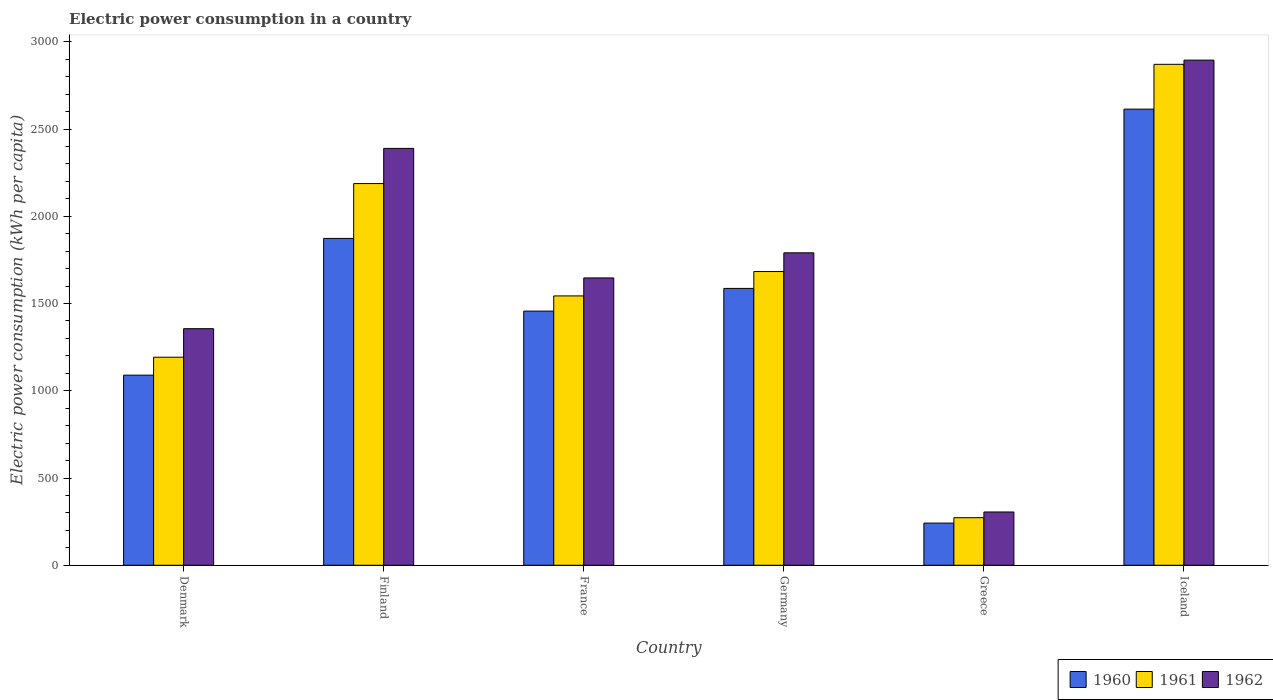How many different coloured bars are there?
Your response must be concise. 3. Are the number of bars per tick equal to the number of legend labels?
Your response must be concise. Yes. Are the number of bars on each tick of the X-axis equal?
Provide a short and direct response. Yes. What is the label of the 4th group of bars from the left?
Your answer should be compact. Germany. In how many cases, is the number of bars for a given country not equal to the number of legend labels?
Offer a very short reply. 0. What is the electric power consumption in in 1961 in Germany?
Ensure brevity in your answer.  1683.41. Across all countries, what is the maximum electric power consumption in in 1962?
Provide a succinct answer. 2895.09. Across all countries, what is the minimum electric power consumption in in 1962?
Give a very brief answer. 305.39. What is the total electric power consumption in in 1962 in the graph?
Your answer should be very brief. 1.04e+04. What is the difference between the electric power consumption in in 1960 in Finland and that in Iceland?
Give a very brief answer. -740.99. What is the difference between the electric power consumption in in 1960 in Iceland and the electric power consumption in in 1962 in Greece?
Your answer should be very brief. 2308.89. What is the average electric power consumption in in 1960 per country?
Ensure brevity in your answer.  1477.06. What is the difference between the electric power consumption in of/in 1960 and electric power consumption in of/in 1962 in Iceland?
Provide a short and direct response. -280.8. In how many countries, is the electric power consumption in in 1960 greater than 1600 kWh per capita?
Your response must be concise. 2. What is the ratio of the electric power consumption in in 1960 in France to that in Iceland?
Provide a succinct answer. 0.56. Is the difference between the electric power consumption in in 1960 in Denmark and Greece greater than the difference between the electric power consumption in in 1962 in Denmark and Greece?
Provide a succinct answer. No. What is the difference between the highest and the second highest electric power consumption in in 1962?
Provide a short and direct response. 598.52. What is the difference between the highest and the lowest electric power consumption in in 1960?
Offer a very short reply. 2372.56. In how many countries, is the electric power consumption in in 1960 greater than the average electric power consumption in in 1960 taken over all countries?
Make the answer very short. 3. What does the 3rd bar from the right in France represents?
Make the answer very short. 1960. Is it the case that in every country, the sum of the electric power consumption in in 1960 and electric power consumption in in 1962 is greater than the electric power consumption in in 1961?
Ensure brevity in your answer.  Yes. How many countries are there in the graph?
Keep it short and to the point. 6. Does the graph contain any zero values?
Give a very brief answer. No. Does the graph contain grids?
Offer a terse response. No. What is the title of the graph?
Keep it short and to the point. Electric power consumption in a country. What is the label or title of the Y-axis?
Ensure brevity in your answer.  Electric power consumption (kWh per capita). What is the Electric power consumption (kWh per capita) of 1960 in Denmark?
Your response must be concise. 1089.61. What is the Electric power consumption (kWh per capita) of 1961 in Denmark?
Your answer should be compact. 1192.41. What is the Electric power consumption (kWh per capita) of 1962 in Denmark?
Your answer should be very brief. 1355.93. What is the Electric power consumption (kWh per capita) of 1960 in Finland?
Give a very brief answer. 1873.29. What is the Electric power consumption (kWh per capita) of 1961 in Finland?
Make the answer very short. 2187.62. What is the Electric power consumption (kWh per capita) in 1962 in Finland?
Your answer should be compact. 2389.21. What is the Electric power consumption (kWh per capita) in 1960 in France?
Your answer should be compact. 1456.69. What is the Electric power consumption (kWh per capita) in 1961 in France?
Provide a short and direct response. 1543.71. What is the Electric power consumption (kWh per capita) of 1962 in France?
Keep it short and to the point. 1646.83. What is the Electric power consumption (kWh per capita) in 1960 in Germany?
Your answer should be compact. 1586.75. What is the Electric power consumption (kWh per capita) in 1961 in Germany?
Ensure brevity in your answer.  1683.41. What is the Electric power consumption (kWh per capita) of 1962 in Germany?
Keep it short and to the point. 1790.69. What is the Electric power consumption (kWh per capita) of 1960 in Greece?
Your answer should be compact. 241.73. What is the Electric power consumption (kWh per capita) in 1961 in Greece?
Your response must be concise. 272.56. What is the Electric power consumption (kWh per capita) in 1962 in Greece?
Offer a terse response. 305.39. What is the Electric power consumption (kWh per capita) in 1960 in Iceland?
Provide a succinct answer. 2614.28. What is the Electric power consumption (kWh per capita) of 1961 in Iceland?
Provide a succinct answer. 2871.04. What is the Electric power consumption (kWh per capita) of 1962 in Iceland?
Offer a very short reply. 2895.09. Across all countries, what is the maximum Electric power consumption (kWh per capita) in 1960?
Provide a succinct answer. 2614.28. Across all countries, what is the maximum Electric power consumption (kWh per capita) of 1961?
Your response must be concise. 2871.04. Across all countries, what is the maximum Electric power consumption (kWh per capita) in 1962?
Ensure brevity in your answer.  2895.09. Across all countries, what is the minimum Electric power consumption (kWh per capita) of 1960?
Make the answer very short. 241.73. Across all countries, what is the minimum Electric power consumption (kWh per capita) in 1961?
Provide a succinct answer. 272.56. Across all countries, what is the minimum Electric power consumption (kWh per capita) in 1962?
Offer a very short reply. 305.39. What is the total Electric power consumption (kWh per capita) in 1960 in the graph?
Give a very brief answer. 8862.36. What is the total Electric power consumption (kWh per capita) of 1961 in the graph?
Make the answer very short. 9750.76. What is the total Electric power consumption (kWh per capita) in 1962 in the graph?
Provide a succinct answer. 1.04e+04. What is the difference between the Electric power consumption (kWh per capita) of 1960 in Denmark and that in Finland?
Your answer should be very brief. -783.68. What is the difference between the Electric power consumption (kWh per capita) of 1961 in Denmark and that in Finland?
Provide a succinct answer. -995.22. What is the difference between the Electric power consumption (kWh per capita) in 1962 in Denmark and that in Finland?
Provide a succinct answer. -1033.28. What is the difference between the Electric power consumption (kWh per capita) in 1960 in Denmark and that in France?
Provide a succinct answer. -367.08. What is the difference between the Electric power consumption (kWh per capita) in 1961 in Denmark and that in France?
Your response must be concise. -351.31. What is the difference between the Electric power consumption (kWh per capita) in 1962 in Denmark and that in France?
Provide a succinct answer. -290.9. What is the difference between the Electric power consumption (kWh per capita) of 1960 in Denmark and that in Germany?
Make the answer very short. -497.14. What is the difference between the Electric power consumption (kWh per capita) in 1961 in Denmark and that in Germany?
Give a very brief answer. -491.01. What is the difference between the Electric power consumption (kWh per capita) of 1962 in Denmark and that in Germany?
Give a very brief answer. -434.76. What is the difference between the Electric power consumption (kWh per capita) in 1960 in Denmark and that in Greece?
Provide a succinct answer. 847.89. What is the difference between the Electric power consumption (kWh per capita) in 1961 in Denmark and that in Greece?
Your response must be concise. 919.84. What is the difference between the Electric power consumption (kWh per capita) in 1962 in Denmark and that in Greece?
Your response must be concise. 1050.54. What is the difference between the Electric power consumption (kWh per capita) in 1960 in Denmark and that in Iceland?
Your response must be concise. -1524.67. What is the difference between the Electric power consumption (kWh per capita) of 1961 in Denmark and that in Iceland?
Keep it short and to the point. -1678.64. What is the difference between the Electric power consumption (kWh per capita) of 1962 in Denmark and that in Iceland?
Your answer should be compact. -1539.15. What is the difference between the Electric power consumption (kWh per capita) of 1960 in Finland and that in France?
Offer a terse response. 416.6. What is the difference between the Electric power consumption (kWh per capita) in 1961 in Finland and that in France?
Offer a terse response. 643.91. What is the difference between the Electric power consumption (kWh per capita) in 1962 in Finland and that in France?
Your answer should be very brief. 742.38. What is the difference between the Electric power consumption (kWh per capita) of 1960 in Finland and that in Germany?
Provide a short and direct response. 286.54. What is the difference between the Electric power consumption (kWh per capita) of 1961 in Finland and that in Germany?
Provide a succinct answer. 504.21. What is the difference between the Electric power consumption (kWh per capita) in 1962 in Finland and that in Germany?
Your answer should be compact. 598.52. What is the difference between the Electric power consumption (kWh per capita) of 1960 in Finland and that in Greece?
Make the answer very short. 1631.57. What is the difference between the Electric power consumption (kWh per capita) in 1961 in Finland and that in Greece?
Your response must be concise. 1915.06. What is the difference between the Electric power consumption (kWh per capita) in 1962 in Finland and that in Greece?
Keep it short and to the point. 2083.82. What is the difference between the Electric power consumption (kWh per capita) in 1960 in Finland and that in Iceland?
Your answer should be very brief. -740.99. What is the difference between the Electric power consumption (kWh per capita) in 1961 in Finland and that in Iceland?
Provide a short and direct response. -683.42. What is the difference between the Electric power consumption (kWh per capita) of 1962 in Finland and that in Iceland?
Provide a short and direct response. -505.88. What is the difference between the Electric power consumption (kWh per capita) in 1960 in France and that in Germany?
Keep it short and to the point. -130.06. What is the difference between the Electric power consumption (kWh per capita) in 1961 in France and that in Germany?
Your response must be concise. -139.7. What is the difference between the Electric power consumption (kWh per capita) in 1962 in France and that in Germany?
Provide a succinct answer. -143.85. What is the difference between the Electric power consumption (kWh per capita) of 1960 in France and that in Greece?
Offer a very short reply. 1214.97. What is the difference between the Electric power consumption (kWh per capita) in 1961 in France and that in Greece?
Ensure brevity in your answer.  1271.15. What is the difference between the Electric power consumption (kWh per capita) of 1962 in France and that in Greece?
Keep it short and to the point. 1341.44. What is the difference between the Electric power consumption (kWh per capita) of 1960 in France and that in Iceland?
Provide a short and direct response. -1157.59. What is the difference between the Electric power consumption (kWh per capita) in 1961 in France and that in Iceland?
Your answer should be very brief. -1327.33. What is the difference between the Electric power consumption (kWh per capita) of 1962 in France and that in Iceland?
Keep it short and to the point. -1248.25. What is the difference between the Electric power consumption (kWh per capita) of 1960 in Germany and that in Greece?
Your response must be concise. 1345.02. What is the difference between the Electric power consumption (kWh per capita) of 1961 in Germany and that in Greece?
Offer a terse response. 1410.85. What is the difference between the Electric power consumption (kWh per capita) in 1962 in Germany and that in Greece?
Keep it short and to the point. 1485.3. What is the difference between the Electric power consumption (kWh per capita) of 1960 in Germany and that in Iceland?
Make the answer very short. -1027.53. What is the difference between the Electric power consumption (kWh per capita) in 1961 in Germany and that in Iceland?
Ensure brevity in your answer.  -1187.63. What is the difference between the Electric power consumption (kWh per capita) of 1962 in Germany and that in Iceland?
Make the answer very short. -1104.4. What is the difference between the Electric power consumption (kWh per capita) in 1960 in Greece and that in Iceland?
Give a very brief answer. -2372.56. What is the difference between the Electric power consumption (kWh per capita) of 1961 in Greece and that in Iceland?
Keep it short and to the point. -2598.48. What is the difference between the Electric power consumption (kWh per capita) of 1962 in Greece and that in Iceland?
Provide a succinct answer. -2589.7. What is the difference between the Electric power consumption (kWh per capita) in 1960 in Denmark and the Electric power consumption (kWh per capita) in 1961 in Finland?
Ensure brevity in your answer.  -1098.01. What is the difference between the Electric power consumption (kWh per capita) in 1960 in Denmark and the Electric power consumption (kWh per capita) in 1962 in Finland?
Provide a succinct answer. -1299.6. What is the difference between the Electric power consumption (kWh per capita) in 1961 in Denmark and the Electric power consumption (kWh per capita) in 1962 in Finland?
Provide a succinct answer. -1196.8. What is the difference between the Electric power consumption (kWh per capita) of 1960 in Denmark and the Electric power consumption (kWh per capita) of 1961 in France?
Make the answer very short. -454.1. What is the difference between the Electric power consumption (kWh per capita) of 1960 in Denmark and the Electric power consumption (kWh per capita) of 1962 in France?
Give a very brief answer. -557.22. What is the difference between the Electric power consumption (kWh per capita) in 1961 in Denmark and the Electric power consumption (kWh per capita) in 1962 in France?
Give a very brief answer. -454.43. What is the difference between the Electric power consumption (kWh per capita) in 1960 in Denmark and the Electric power consumption (kWh per capita) in 1961 in Germany?
Offer a terse response. -593.8. What is the difference between the Electric power consumption (kWh per capita) of 1960 in Denmark and the Electric power consumption (kWh per capita) of 1962 in Germany?
Make the answer very short. -701.07. What is the difference between the Electric power consumption (kWh per capita) in 1961 in Denmark and the Electric power consumption (kWh per capita) in 1962 in Germany?
Keep it short and to the point. -598.28. What is the difference between the Electric power consumption (kWh per capita) of 1960 in Denmark and the Electric power consumption (kWh per capita) of 1961 in Greece?
Provide a short and direct response. 817.05. What is the difference between the Electric power consumption (kWh per capita) in 1960 in Denmark and the Electric power consumption (kWh per capita) in 1962 in Greece?
Provide a succinct answer. 784.22. What is the difference between the Electric power consumption (kWh per capita) of 1961 in Denmark and the Electric power consumption (kWh per capita) of 1962 in Greece?
Provide a succinct answer. 887.02. What is the difference between the Electric power consumption (kWh per capita) of 1960 in Denmark and the Electric power consumption (kWh per capita) of 1961 in Iceland?
Ensure brevity in your answer.  -1781.43. What is the difference between the Electric power consumption (kWh per capita) of 1960 in Denmark and the Electric power consumption (kWh per capita) of 1962 in Iceland?
Offer a terse response. -1805.47. What is the difference between the Electric power consumption (kWh per capita) in 1961 in Denmark and the Electric power consumption (kWh per capita) in 1962 in Iceland?
Provide a succinct answer. -1702.68. What is the difference between the Electric power consumption (kWh per capita) in 1960 in Finland and the Electric power consumption (kWh per capita) in 1961 in France?
Provide a succinct answer. 329.58. What is the difference between the Electric power consumption (kWh per capita) in 1960 in Finland and the Electric power consumption (kWh per capita) in 1962 in France?
Give a very brief answer. 226.46. What is the difference between the Electric power consumption (kWh per capita) of 1961 in Finland and the Electric power consumption (kWh per capita) of 1962 in France?
Your response must be concise. 540.79. What is the difference between the Electric power consumption (kWh per capita) in 1960 in Finland and the Electric power consumption (kWh per capita) in 1961 in Germany?
Offer a very short reply. 189.88. What is the difference between the Electric power consumption (kWh per capita) of 1960 in Finland and the Electric power consumption (kWh per capita) of 1962 in Germany?
Ensure brevity in your answer.  82.61. What is the difference between the Electric power consumption (kWh per capita) in 1961 in Finland and the Electric power consumption (kWh per capita) in 1962 in Germany?
Provide a short and direct response. 396.94. What is the difference between the Electric power consumption (kWh per capita) of 1960 in Finland and the Electric power consumption (kWh per capita) of 1961 in Greece?
Your response must be concise. 1600.73. What is the difference between the Electric power consumption (kWh per capita) of 1960 in Finland and the Electric power consumption (kWh per capita) of 1962 in Greece?
Give a very brief answer. 1567.9. What is the difference between the Electric power consumption (kWh per capita) in 1961 in Finland and the Electric power consumption (kWh per capita) in 1962 in Greece?
Your response must be concise. 1882.23. What is the difference between the Electric power consumption (kWh per capita) of 1960 in Finland and the Electric power consumption (kWh per capita) of 1961 in Iceland?
Give a very brief answer. -997.75. What is the difference between the Electric power consumption (kWh per capita) in 1960 in Finland and the Electric power consumption (kWh per capita) in 1962 in Iceland?
Ensure brevity in your answer.  -1021.79. What is the difference between the Electric power consumption (kWh per capita) of 1961 in Finland and the Electric power consumption (kWh per capita) of 1962 in Iceland?
Offer a terse response. -707.46. What is the difference between the Electric power consumption (kWh per capita) of 1960 in France and the Electric power consumption (kWh per capita) of 1961 in Germany?
Ensure brevity in your answer.  -226.72. What is the difference between the Electric power consumption (kWh per capita) of 1960 in France and the Electric power consumption (kWh per capita) of 1962 in Germany?
Make the answer very short. -333.99. What is the difference between the Electric power consumption (kWh per capita) in 1961 in France and the Electric power consumption (kWh per capita) in 1962 in Germany?
Offer a terse response. -246.98. What is the difference between the Electric power consumption (kWh per capita) of 1960 in France and the Electric power consumption (kWh per capita) of 1961 in Greece?
Provide a short and direct response. 1184.13. What is the difference between the Electric power consumption (kWh per capita) of 1960 in France and the Electric power consumption (kWh per capita) of 1962 in Greece?
Ensure brevity in your answer.  1151.3. What is the difference between the Electric power consumption (kWh per capita) in 1961 in France and the Electric power consumption (kWh per capita) in 1962 in Greece?
Ensure brevity in your answer.  1238.32. What is the difference between the Electric power consumption (kWh per capita) in 1960 in France and the Electric power consumption (kWh per capita) in 1961 in Iceland?
Your answer should be very brief. -1414.35. What is the difference between the Electric power consumption (kWh per capita) in 1960 in France and the Electric power consumption (kWh per capita) in 1962 in Iceland?
Offer a terse response. -1438.39. What is the difference between the Electric power consumption (kWh per capita) in 1961 in France and the Electric power consumption (kWh per capita) in 1962 in Iceland?
Your response must be concise. -1351.37. What is the difference between the Electric power consumption (kWh per capita) in 1960 in Germany and the Electric power consumption (kWh per capita) in 1961 in Greece?
Ensure brevity in your answer.  1314.19. What is the difference between the Electric power consumption (kWh per capita) of 1960 in Germany and the Electric power consumption (kWh per capita) of 1962 in Greece?
Your answer should be very brief. 1281.36. What is the difference between the Electric power consumption (kWh per capita) of 1961 in Germany and the Electric power consumption (kWh per capita) of 1962 in Greece?
Provide a succinct answer. 1378.03. What is the difference between the Electric power consumption (kWh per capita) in 1960 in Germany and the Electric power consumption (kWh per capita) in 1961 in Iceland?
Provide a succinct answer. -1284.29. What is the difference between the Electric power consumption (kWh per capita) in 1960 in Germany and the Electric power consumption (kWh per capita) in 1962 in Iceland?
Provide a succinct answer. -1308.34. What is the difference between the Electric power consumption (kWh per capita) of 1961 in Germany and the Electric power consumption (kWh per capita) of 1962 in Iceland?
Offer a very short reply. -1211.67. What is the difference between the Electric power consumption (kWh per capita) of 1960 in Greece and the Electric power consumption (kWh per capita) of 1961 in Iceland?
Offer a very short reply. -2629.32. What is the difference between the Electric power consumption (kWh per capita) of 1960 in Greece and the Electric power consumption (kWh per capita) of 1962 in Iceland?
Offer a very short reply. -2653.36. What is the difference between the Electric power consumption (kWh per capita) in 1961 in Greece and the Electric power consumption (kWh per capita) in 1962 in Iceland?
Your answer should be compact. -2622.52. What is the average Electric power consumption (kWh per capita) of 1960 per country?
Ensure brevity in your answer.  1477.06. What is the average Electric power consumption (kWh per capita) in 1961 per country?
Provide a short and direct response. 1625.13. What is the average Electric power consumption (kWh per capita) of 1962 per country?
Provide a short and direct response. 1730.52. What is the difference between the Electric power consumption (kWh per capita) of 1960 and Electric power consumption (kWh per capita) of 1961 in Denmark?
Provide a succinct answer. -102.79. What is the difference between the Electric power consumption (kWh per capita) of 1960 and Electric power consumption (kWh per capita) of 1962 in Denmark?
Make the answer very short. -266.32. What is the difference between the Electric power consumption (kWh per capita) in 1961 and Electric power consumption (kWh per capita) in 1962 in Denmark?
Your answer should be compact. -163.53. What is the difference between the Electric power consumption (kWh per capita) in 1960 and Electric power consumption (kWh per capita) in 1961 in Finland?
Your response must be concise. -314.33. What is the difference between the Electric power consumption (kWh per capita) of 1960 and Electric power consumption (kWh per capita) of 1962 in Finland?
Offer a very short reply. -515.92. What is the difference between the Electric power consumption (kWh per capita) in 1961 and Electric power consumption (kWh per capita) in 1962 in Finland?
Offer a very short reply. -201.59. What is the difference between the Electric power consumption (kWh per capita) of 1960 and Electric power consumption (kWh per capita) of 1961 in France?
Your response must be concise. -87.02. What is the difference between the Electric power consumption (kWh per capita) in 1960 and Electric power consumption (kWh per capita) in 1962 in France?
Your answer should be very brief. -190.14. What is the difference between the Electric power consumption (kWh per capita) of 1961 and Electric power consumption (kWh per capita) of 1962 in France?
Give a very brief answer. -103.12. What is the difference between the Electric power consumption (kWh per capita) in 1960 and Electric power consumption (kWh per capita) in 1961 in Germany?
Make the answer very short. -96.67. What is the difference between the Electric power consumption (kWh per capita) of 1960 and Electric power consumption (kWh per capita) of 1962 in Germany?
Give a very brief answer. -203.94. What is the difference between the Electric power consumption (kWh per capita) in 1961 and Electric power consumption (kWh per capita) in 1962 in Germany?
Provide a short and direct response. -107.27. What is the difference between the Electric power consumption (kWh per capita) in 1960 and Electric power consumption (kWh per capita) in 1961 in Greece?
Offer a very short reply. -30.84. What is the difference between the Electric power consumption (kWh per capita) in 1960 and Electric power consumption (kWh per capita) in 1962 in Greece?
Your answer should be compact. -63.66. What is the difference between the Electric power consumption (kWh per capita) in 1961 and Electric power consumption (kWh per capita) in 1962 in Greece?
Your response must be concise. -32.83. What is the difference between the Electric power consumption (kWh per capita) of 1960 and Electric power consumption (kWh per capita) of 1961 in Iceland?
Give a very brief answer. -256.76. What is the difference between the Electric power consumption (kWh per capita) in 1960 and Electric power consumption (kWh per capita) in 1962 in Iceland?
Offer a very short reply. -280.8. What is the difference between the Electric power consumption (kWh per capita) of 1961 and Electric power consumption (kWh per capita) of 1962 in Iceland?
Your answer should be very brief. -24.04. What is the ratio of the Electric power consumption (kWh per capita) of 1960 in Denmark to that in Finland?
Your answer should be compact. 0.58. What is the ratio of the Electric power consumption (kWh per capita) of 1961 in Denmark to that in Finland?
Offer a terse response. 0.55. What is the ratio of the Electric power consumption (kWh per capita) of 1962 in Denmark to that in Finland?
Your answer should be very brief. 0.57. What is the ratio of the Electric power consumption (kWh per capita) in 1960 in Denmark to that in France?
Give a very brief answer. 0.75. What is the ratio of the Electric power consumption (kWh per capita) of 1961 in Denmark to that in France?
Provide a short and direct response. 0.77. What is the ratio of the Electric power consumption (kWh per capita) of 1962 in Denmark to that in France?
Provide a succinct answer. 0.82. What is the ratio of the Electric power consumption (kWh per capita) in 1960 in Denmark to that in Germany?
Give a very brief answer. 0.69. What is the ratio of the Electric power consumption (kWh per capita) in 1961 in Denmark to that in Germany?
Ensure brevity in your answer.  0.71. What is the ratio of the Electric power consumption (kWh per capita) in 1962 in Denmark to that in Germany?
Make the answer very short. 0.76. What is the ratio of the Electric power consumption (kWh per capita) of 1960 in Denmark to that in Greece?
Keep it short and to the point. 4.51. What is the ratio of the Electric power consumption (kWh per capita) of 1961 in Denmark to that in Greece?
Give a very brief answer. 4.37. What is the ratio of the Electric power consumption (kWh per capita) in 1962 in Denmark to that in Greece?
Your answer should be compact. 4.44. What is the ratio of the Electric power consumption (kWh per capita) in 1960 in Denmark to that in Iceland?
Your answer should be compact. 0.42. What is the ratio of the Electric power consumption (kWh per capita) of 1961 in Denmark to that in Iceland?
Your answer should be compact. 0.42. What is the ratio of the Electric power consumption (kWh per capita) in 1962 in Denmark to that in Iceland?
Provide a short and direct response. 0.47. What is the ratio of the Electric power consumption (kWh per capita) in 1960 in Finland to that in France?
Ensure brevity in your answer.  1.29. What is the ratio of the Electric power consumption (kWh per capita) in 1961 in Finland to that in France?
Provide a succinct answer. 1.42. What is the ratio of the Electric power consumption (kWh per capita) of 1962 in Finland to that in France?
Ensure brevity in your answer.  1.45. What is the ratio of the Electric power consumption (kWh per capita) in 1960 in Finland to that in Germany?
Make the answer very short. 1.18. What is the ratio of the Electric power consumption (kWh per capita) in 1961 in Finland to that in Germany?
Make the answer very short. 1.3. What is the ratio of the Electric power consumption (kWh per capita) of 1962 in Finland to that in Germany?
Ensure brevity in your answer.  1.33. What is the ratio of the Electric power consumption (kWh per capita) in 1960 in Finland to that in Greece?
Give a very brief answer. 7.75. What is the ratio of the Electric power consumption (kWh per capita) in 1961 in Finland to that in Greece?
Offer a very short reply. 8.03. What is the ratio of the Electric power consumption (kWh per capita) in 1962 in Finland to that in Greece?
Provide a succinct answer. 7.82. What is the ratio of the Electric power consumption (kWh per capita) in 1960 in Finland to that in Iceland?
Make the answer very short. 0.72. What is the ratio of the Electric power consumption (kWh per capita) of 1961 in Finland to that in Iceland?
Your response must be concise. 0.76. What is the ratio of the Electric power consumption (kWh per capita) in 1962 in Finland to that in Iceland?
Offer a very short reply. 0.83. What is the ratio of the Electric power consumption (kWh per capita) in 1960 in France to that in Germany?
Your answer should be compact. 0.92. What is the ratio of the Electric power consumption (kWh per capita) in 1961 in France to that in Germany?
Offer a terse response. 0.92. What is the ratio of the Electric power consumption (kWh per capita) in 1962 in France to that in Germany?
Provide a short and direct response. 0.92. What is the ratio of the Electric power consumption (kWh per capita) of 1960 in France to that in Greece?
Keep it short and to the point. 6.03. What is the ratio of the Electric power consumption (kWh per capita) of 1961 in France to that in Greece?
Provide a succinct answer. 5.66. What is the ratio of the Electric power consumption (kWh per capita) of 1962 in France to that in Greece?
Offer a terse response. 5.39. What is the ratio of the Electric power consumption (kWh per capita) in 1960 in France to that in Iceland?
Ensure brevity in your answer.  0.56. What is the ratio of the Electric power consumption (kWh per capita) in 1961 in France to that in Iceland?
Your answer should be compact. 0.54. What is the ratio of the Electric power consumption (kWh per capita) of 1962 in France to that in Iceland?
Give a very brief answer. 0.57. What is the ratio of the Electric power consumption (kWh per capita) in 1960 in Germany to that in Greece?
Keep it short and to the point. 6.56. What is the ratio of the Electric power consumption (kWh per capita) of 1961 in Germany to that in Greece?
Your answer should be very brief. 6.18. What is the ratio of the Electric power consumption (kWh per capita) of 1962 in Germany to that in Greece?
Your response must be concise. 5.86. What is the ratio of the Electric power consumption (kWh per capita) of 1960 in Germany to that in Iceland?
Provide a short and direct response. 0.61. What is the ratio of the Electric power consumption (kWh per capita) in 1961 in Germany to that in Iceland?
Offer a terse response. 0.59. What is the ratio of the Electric power consumption (kWh per capita) in 1962 in Germany to that in Iceland?
Ensure brevity in your answer.  0.62. What is the ratio of the Electric power consumption (kWh per capita) in 1960 in Greece to that in Iceland?
Your answer should be very brief. 0.09. What is the ratio of the Electric power consumption (kWh per capita) in 1961 in Greece to that in Iceland?
Make the answer very short. 0.09. What is the ratio of the Electric power consumption (kWh per capita) of 1962 in Greece to that in Iceland?
Your response must be concise. 0.11. What is the difference between the highest and the second highest Electric power consumption (kWh per capita) in 1960?
Your answer should be very brief. 740.99. What is the difference between the highest and the second highest Electric power consumption (kWh per capita) in 1961?
Your answer should be very brief. 683.42. What is the difference between the highest and the second highest Electric power consumption (kWh per capita) of 1962?
Offer a terse response. 505.88. What is the difference between the highest and the lowest Electric power consumption (kWh per capita) of 1960?
Offer a terse response. 2372.56. What is the difference between the highest and the lowest Electric power consumption (kWh per capita) in 1961?
Your answer should be compact. 2598.48. What is the difference between the highest and the lowest Electric power consumption (kWh per capita) of 1962?
Your response must be concise. 2589.7. 